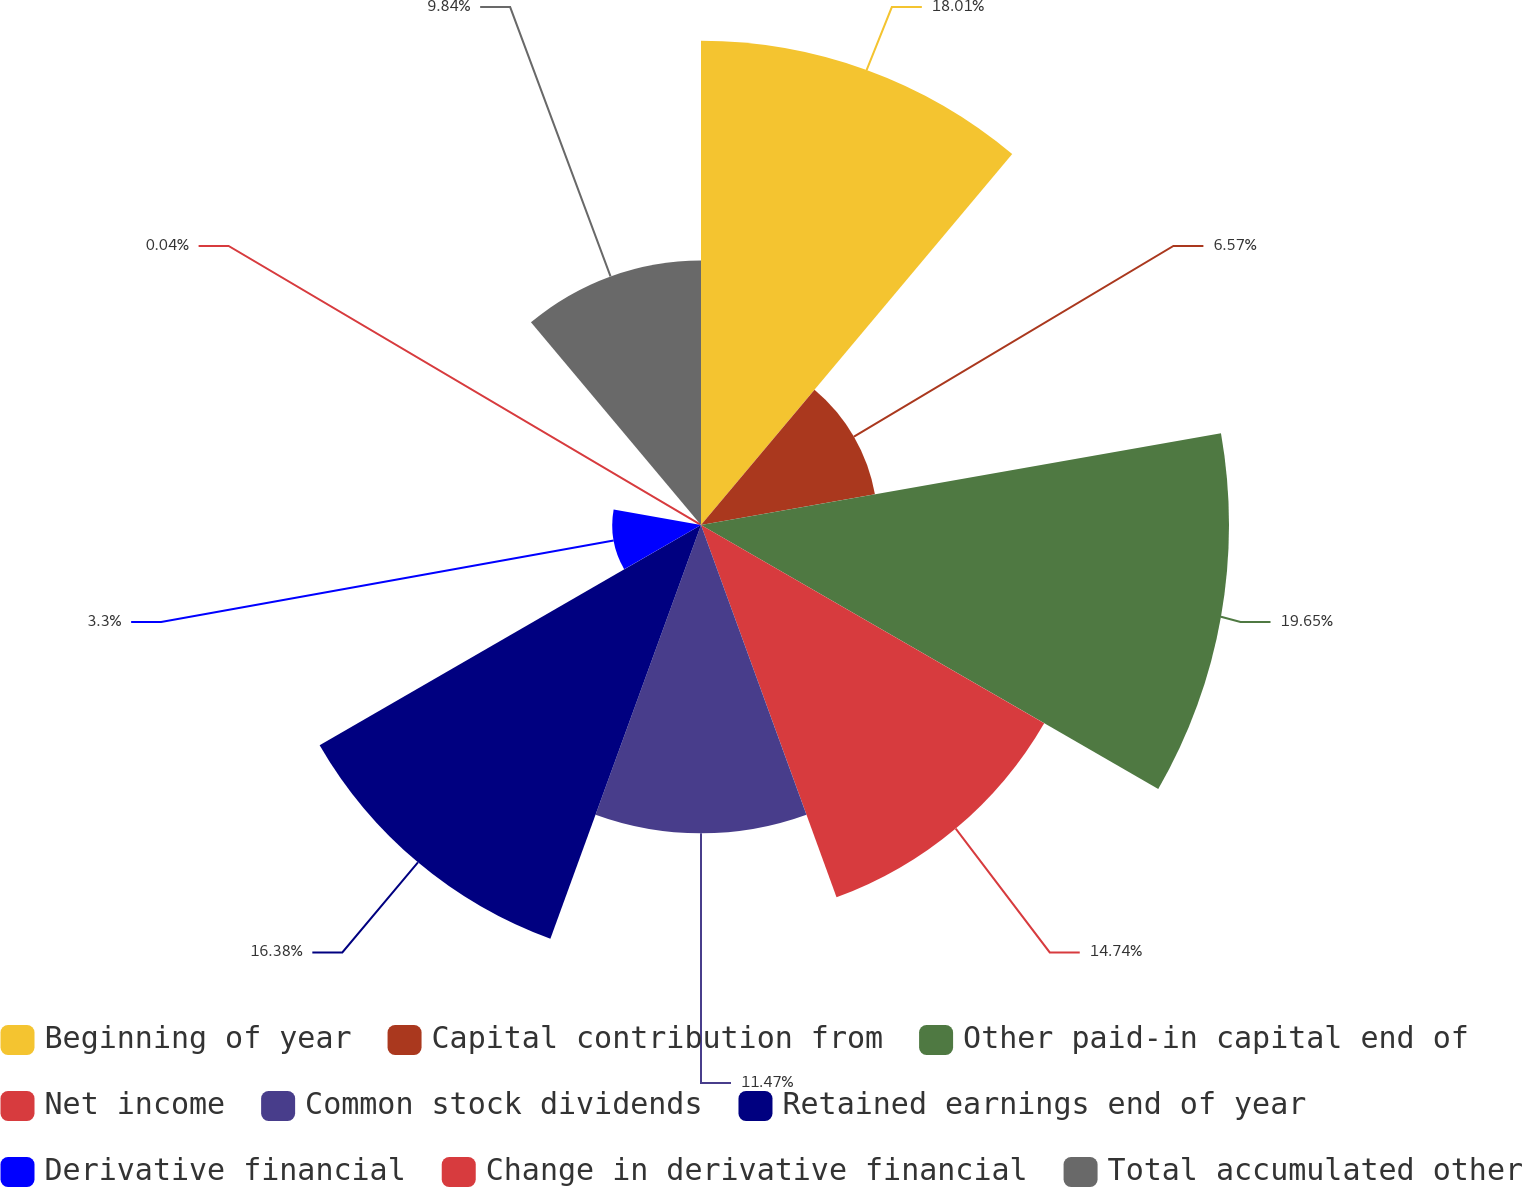<chart> <loc_0><loc_0><loc_500><loc_500><pie_chart><fcel>Beginning of year<fcel>Capital contribution from<fcel>Other paid-in capital end of<fcel>Net income<fcel>Common stock dividends<fcel>Retained earnings end of year<fcel>Derivative financial<fcel>Change in derivative financial<fcel>Total accumulated other<nl><fcel>18.01%<fcel>6.57%<fcel>19.64%<fcel>14.74%<fcel>11.47%<fcel>16.38%<fcel>3.3%<fcel>0.04%<fcel>9.84%<nl></chart> 